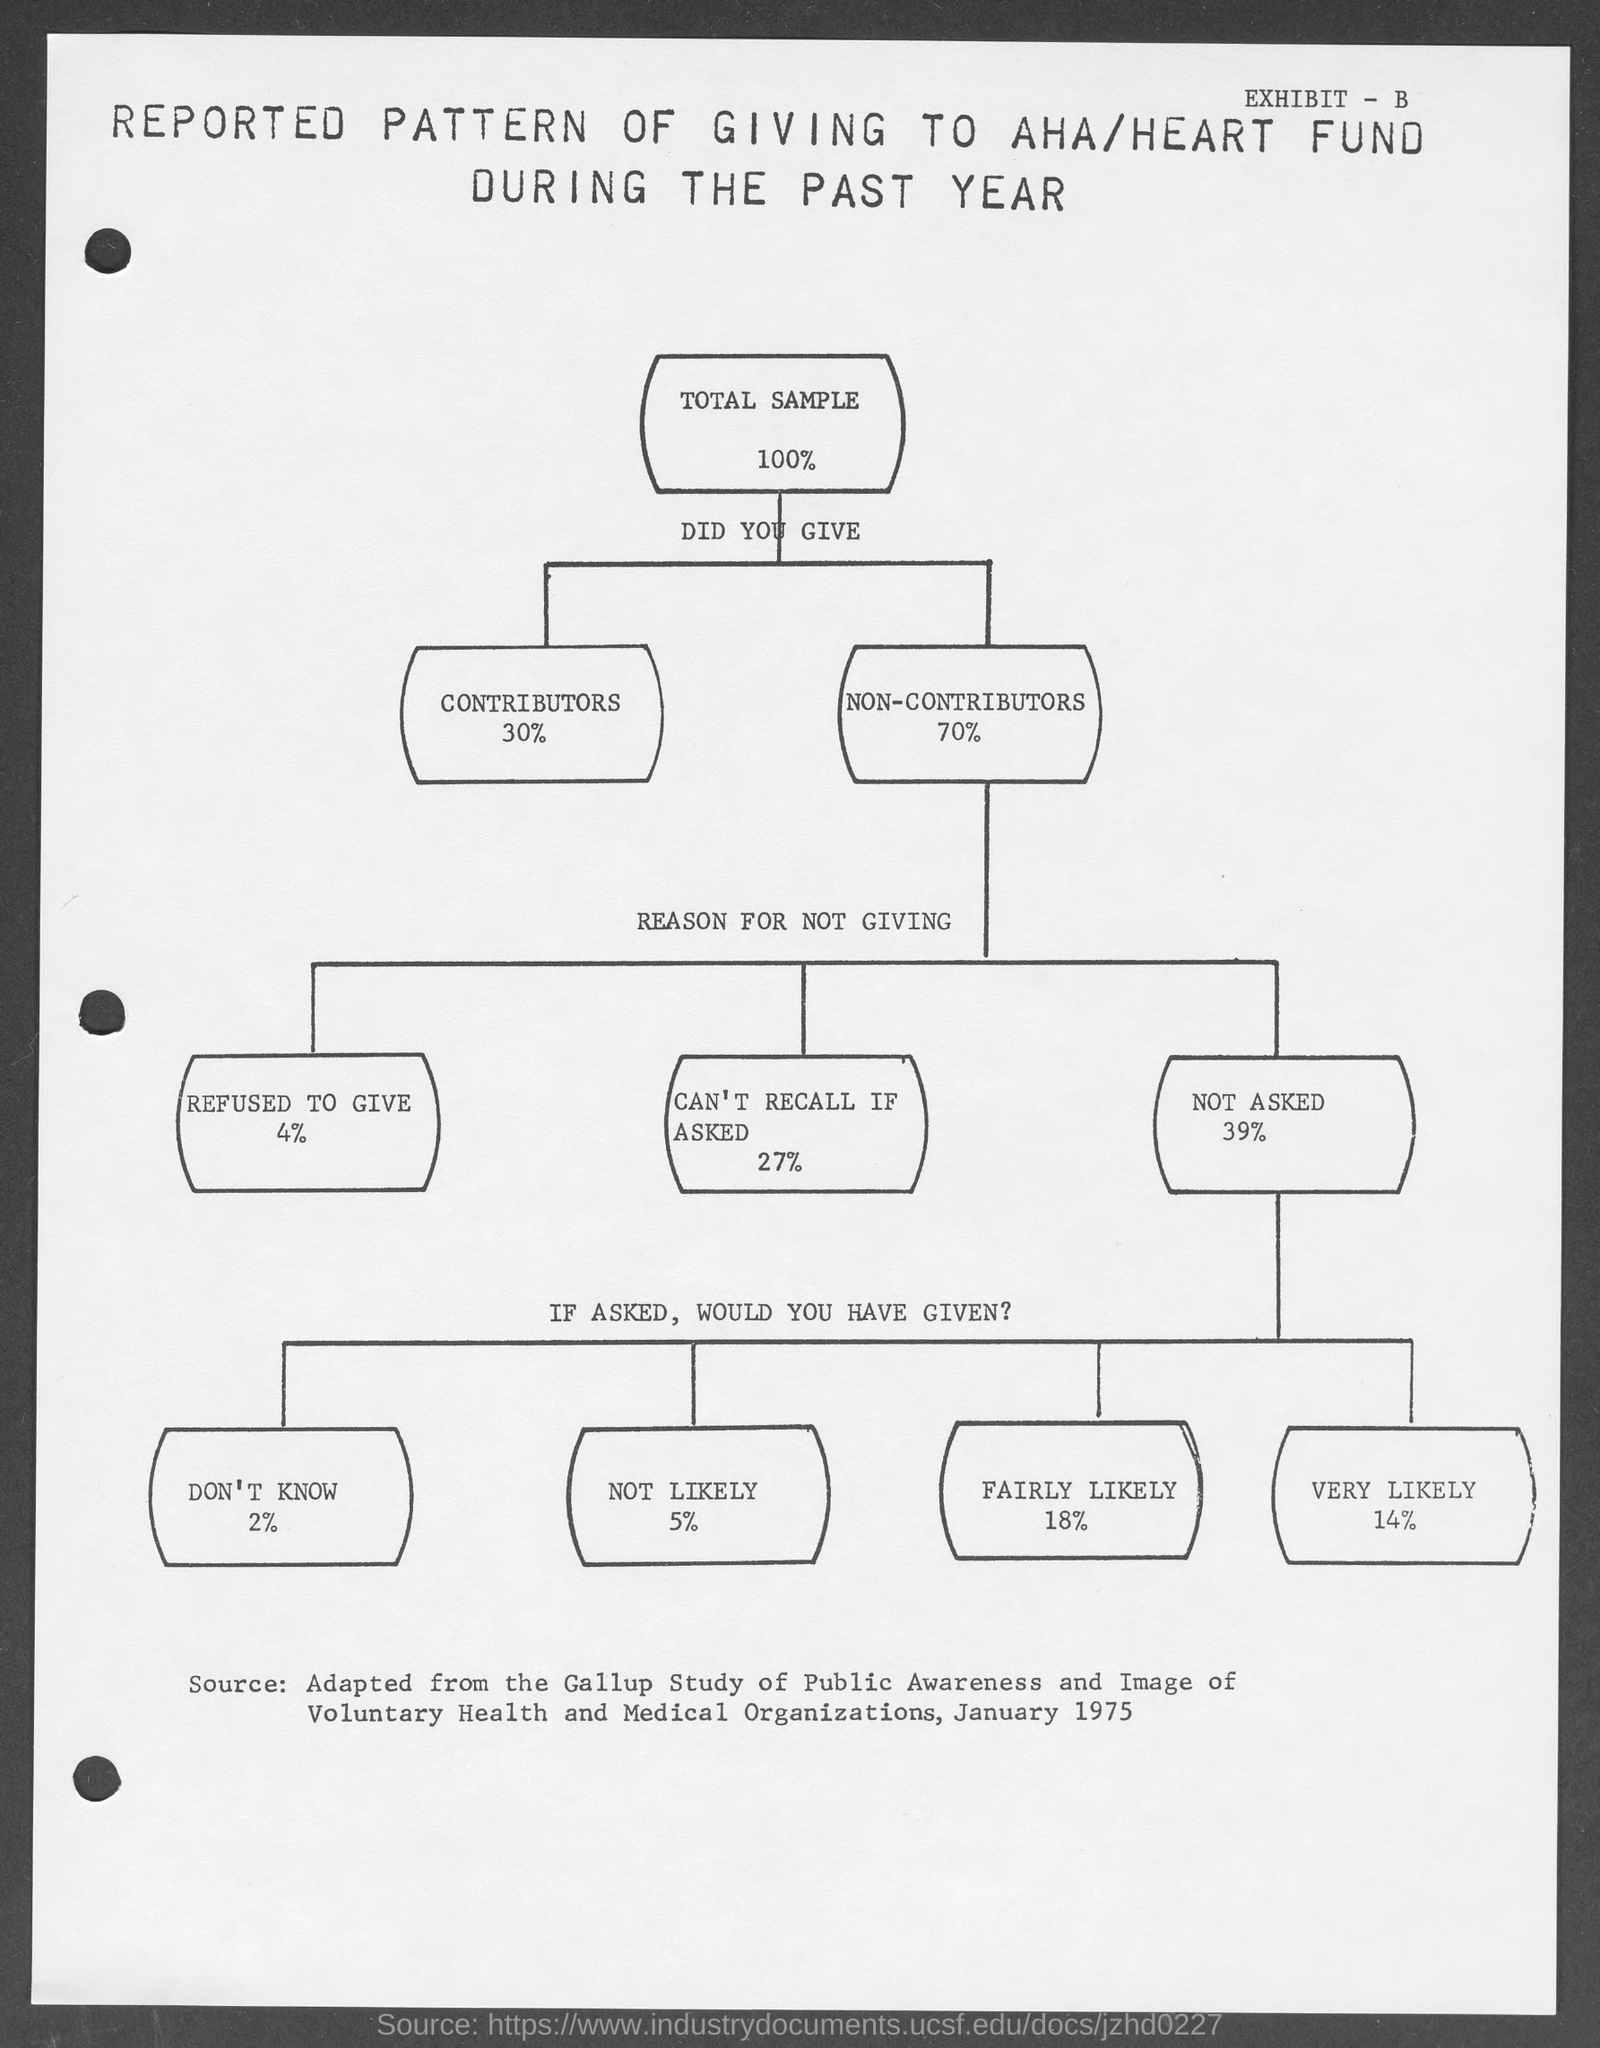What is the % of total sample mentioned in the given page ?
Provide a succinct answer. 100%. What is the % of non-contributors mentioned in the given page ?
Make the answer very short. 70%. What is the % of members refused to give as mentioned in the given page ?
Provide a succinct answer. 4%. What is the % of members said can't recall if asked as a reason for not giving mentioned in the given page ?
Ensure brevity in your answer.  27. What is the % of members thar are not likely for the heart fund as mentioned in the given page ?
Your answer should be compact. 5. What is the % of members that are very likely for the heart fund as mentioned in the given page ?
Make the answer very short. 14%. 